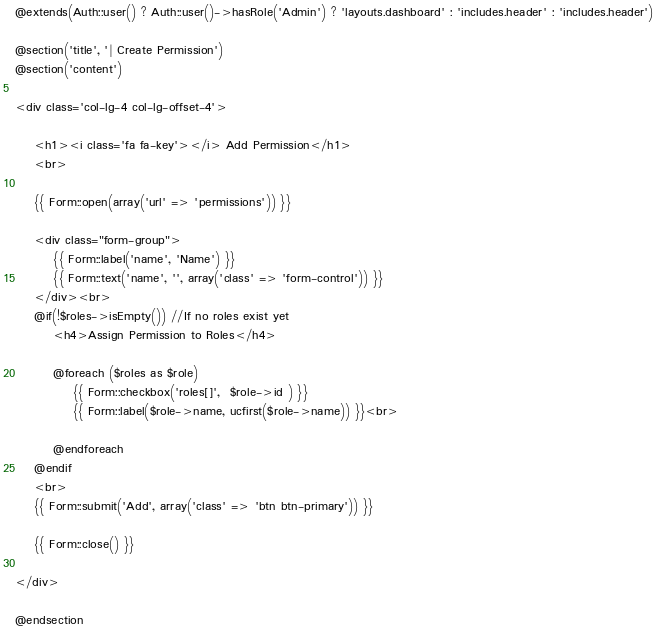Convert code to text. <code><loc_0><loc_0><loc_500><loc_500><_PHP_>@extends(Auth::user() ? Auth::user()->hasRole('Admin') ? 'layouts.dashboard' : 'includes.header' : 'includes.header')

@section('title', '| Create Permission')
@section('content')

<div class='col-lg-4 col-lg-offset-4'>

    <h1><i class='fa fa-key'></i> Add Permission</h1>
    <br>

    {{ Form::open(array('url' => 'permissions')) }}

    <div class="form-group">
        {{ Form::label('name', 'Name') }}
        {{ Form::text('name', '', array('class' => 'form-control')) }}
    </div><br>
    @if(!$roles->isEmpty()) //If no roles exist yet
        <h4>Assign Permission to Roles</h4>

        @foreach ($roles as $role)
            {{ Form::checkbox('roles[]',  $role->id ) }}
            {{ Form::label($role->name, ucfirst($role->name)) }}<br>

        @endforeach
    @endif
    <br>
    {{ Form::submit('Add', array('class' => 'btn btn-primary')) }}

    {{ Form::close() }}

</div>

@endsection
</code> 